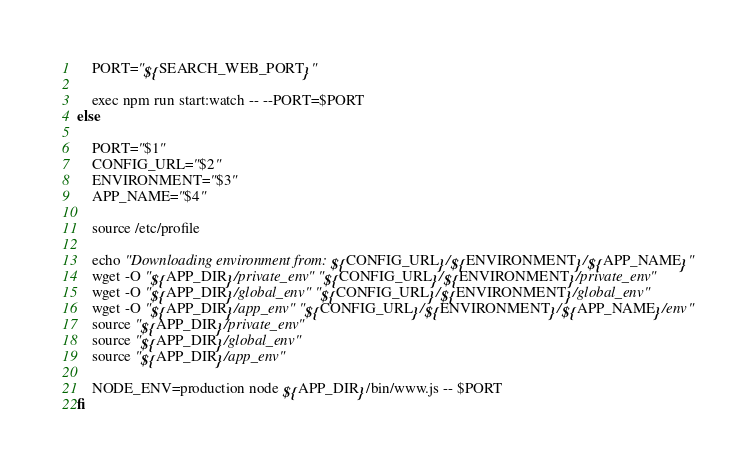Convert code to text. <code><loc_0><loc_0><loc_500><loc_500><_Bash_>
    PORT="${SEARCH_WEB_PORT}"

    exec npm run start:watch -- --PORT=$PORT
else

    PORT="$1"
    CONFIG_URL="$2"
    ENVIRONMENT="$3"
    APP_NAME="$4"

    source /etc/profile

    echo "Downloading environment from: ${CONFIG_URL}/${ENVIRONMENT}/${APP_NAME}"
    wget -O "${APP_DIR}/private_env" "${CONFIG_URL}/${ENVIRONMENT}/private_env"
    wget -O "${APP_DIR}/global_env" "${CONFIG_URL}/${ENVIRONMENT}/global_env"
    wget -O "${APP_DIR}/app_env" "${CONFIG_URL}/${ENVIRONMENT}/${APP_NAME}/env"
    source "${APP_DIR}/private_env"
    source "${APP_DIR}/global_env"
    source "${APP_DIR}/app_env"

    NODE_ENV=production node ${APP_DIR}/bin/www.js -- $PORT
fi </code> 